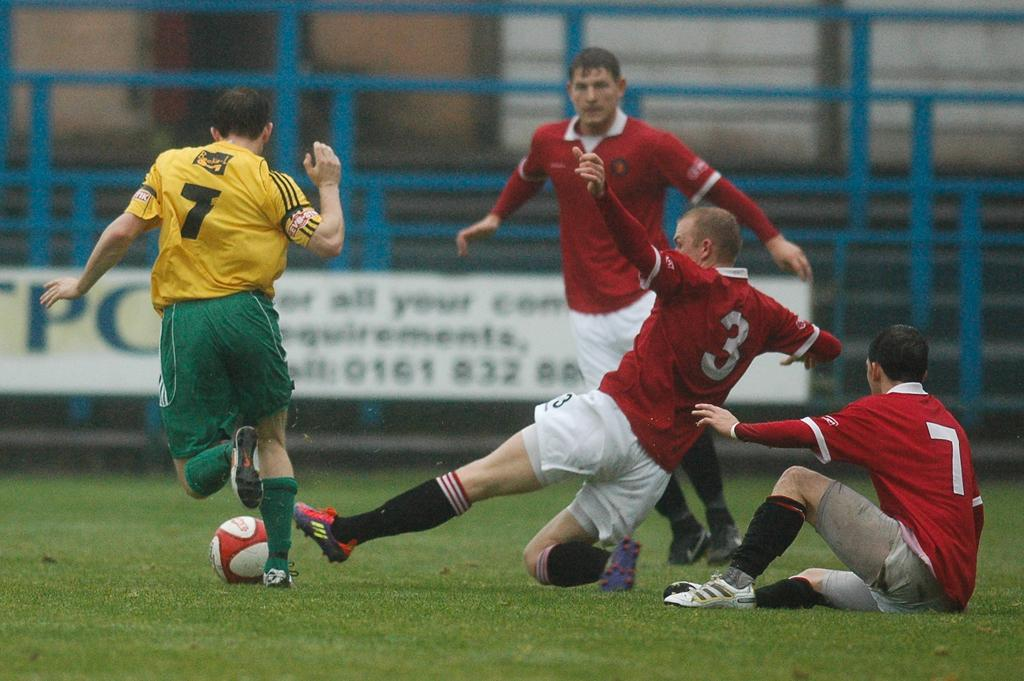Provide a one-sentence caption for the provided image. One man wearing a number 7 shirt is playing soccer against three men wearing red shirts, with the number 3 player attempting to intercept. 